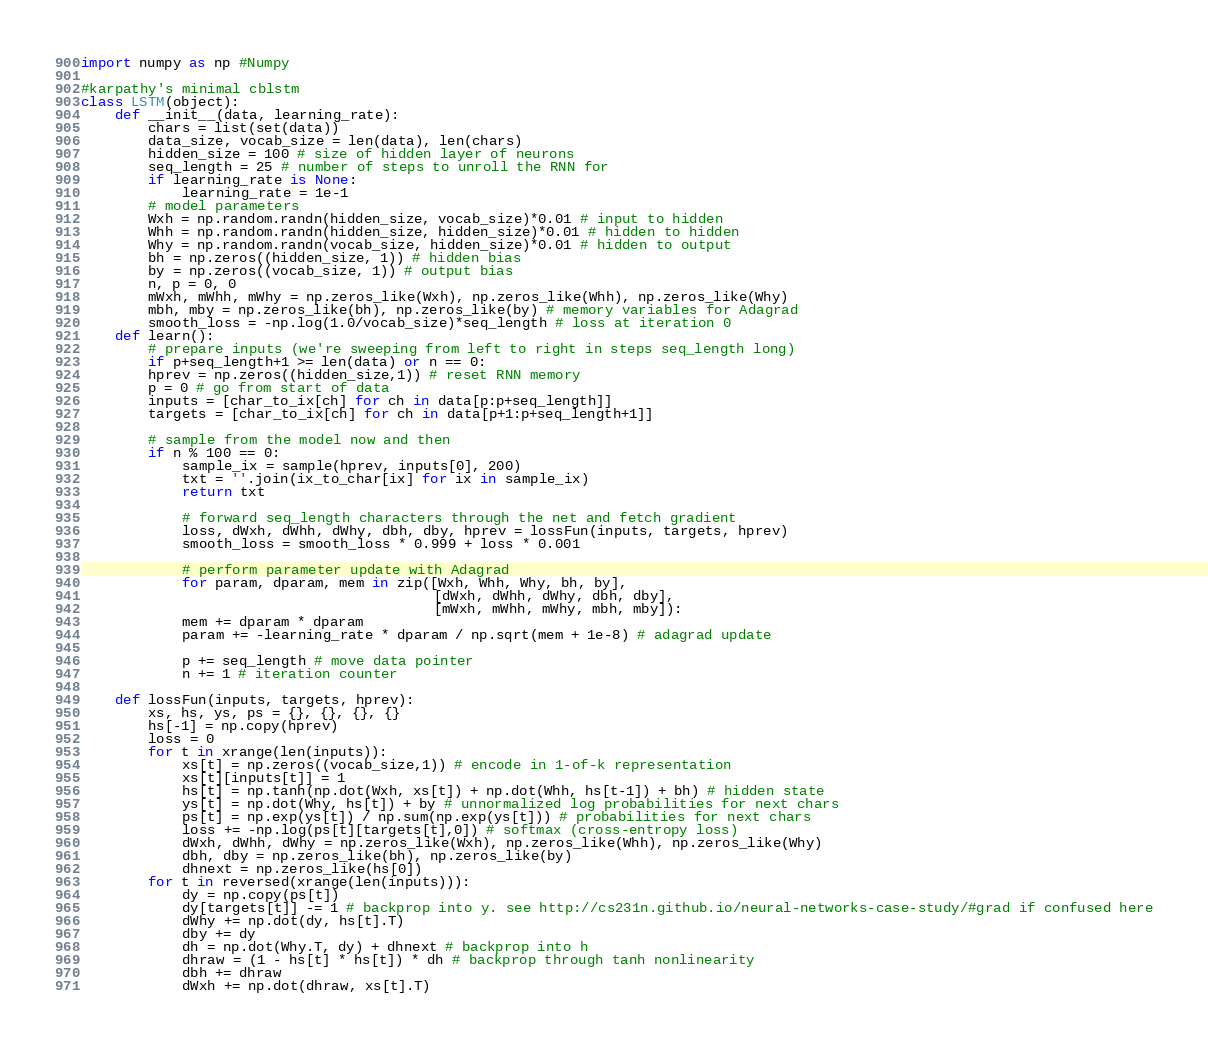<code> <loc_0><loc_0><loc_500><loc_500><_Python_>import numpy as np #Numpy

#karpathy's minimal cblstm
class LSTM(object):
    def __init__(data, learning_rate):     
    	chars = list(set(data))
        data_size, vocab_size = len(data), len(chars)
        hidden_size = 100 # size of hidden layer of neurons
        seq_length = 25 # number of steps to unroll the RNN for
        if learning_rate is None:
        	learning_rate = 1e-1
        # model parameters
        Wxh = np.random.randn(hidden_size, vocab_size)*0.01 # input to hidden
        Whh = np.random.randn(hidden_size, hidden_size)*0.01 # hidden to hidden
        Why = np.random.randn(vocab_size, hidden_size)*0.01 # hidden to output
        bh = np.zeros((hidden_size, 1)) # hidden bias
        by = np.zeros((vocab_size, 1)) # output bias        
        n, p = 0, 0
        mWxh, mWhh, mWhy = np.zeros_like(Wxh), np.zeros_like(Whh), np.zeros_like(Why)
        mbh, mby = np.zeros_like(bh), np.zeros_like(by) # memory variables for Adagrad
        smooth_loss = -np.log(1.0/vocab_size)*seq_length # loss at iteration 0
    def learn():    
        # prepare inputs (we're sweeping from left to right in steps seq_length long)
        if p+seq_length+1 >= len(data) or n == 0: 
        hprev = np.zeros((hidden_size,1)) # reset RNN memory
        p = 0 # go from start of data
        inputs = [char_to_ix[ch] for ch in data[p:p+seq_length]]
        targets = [char_to_ix[ch] for ch in data[p+1:p+seq_length+1]]

        # sample from the model now and then
        if n % 100 == 0:
            sample_ix = sample(hprev, inputs[0], 200)
            txt = ''.join(ix_to_char[ix] for ix in sample_ix)
            return txt

            # forward seq_length characters through the net and fetch gradient
            loss, dWxh, dWhh, dWhy, dbh, dby, hprev = lossFun(inputs, targets, hprev)
            smooth_loss = smooth_loss * 0.999 + loss * 0.001
 
            # perform parameter update with Adagrad
            for param, dparam, mem in zip([Wxh, Whh, Why, bh, by], 
                                          [dWxh, dWhh, dWhy, dbh, dby], 
                                          [mWxh, mWhh, mWhy, mbh, mby]):
            mem += dparam * dparam
            param += -learning_rate * dparam / np.sqrt(mem + 1e-8) # adagrad update

            p += seq_length # move data pointer
            n += 1 # iteration counter 
    
    def lossFun(inputs, targets, hprev):
    	xs, hs, ys, ps = {}, {}, {}, {}
    	hs[-1] = np.copy(hprev)
    	loss = 0
    	for t in xrange(len(inputs)):
      	  	xs[t] = np.zeros((vocab_size,1)) # encode in 1-of-k representation
      	  	xs[t][inputs[t]] = 1
      	  	hs[t] = np.tanh(np.dot(Wxh, xs[t]) + np.dot(Whh, hs[t-1]) + bh) # hidden state
      	  	ys[t] = np.dot(Why, hs[t]) + by # unnormalized log probabilities for next chars
      	  	ps[t] = np.exp(ys[t]) / np.sum(np.exp(ys[t])) # probabilities for next chars
            loss += -np.log(ps[t][targets[t],0]) # softmax (cross-entropy loss)
            dWxh, dWhh, dWhy = np.zeros_like(Wxh), np.zeros_like(Whh), np.zeros_like(Why)
            dbh, dby = np.zeros_like(bh), np.zeros_like(by)
            dhnext = np.zeros_like(hs[0])
        for t in reversed(xrange(len(inputs))):
            dy = np.copy(ps[t])
            dy[targets[t]] -= 1 # backprop into y. see http://cs231n.github.io/neural-networks-case-study/#grad if confused here
            dWhy += np.dot(dy, hs[t].T)
            dby += dy
            dh = np.dot(Why.T, dy) + dhnext # backprop into h
            dhraw = (1 - hs[t] * hs[t]) * dh # backprop through tanh nonlinearity
            dbh += dhraw
            dWxh += np.dot(dhraw, xs[t].T)</code> 